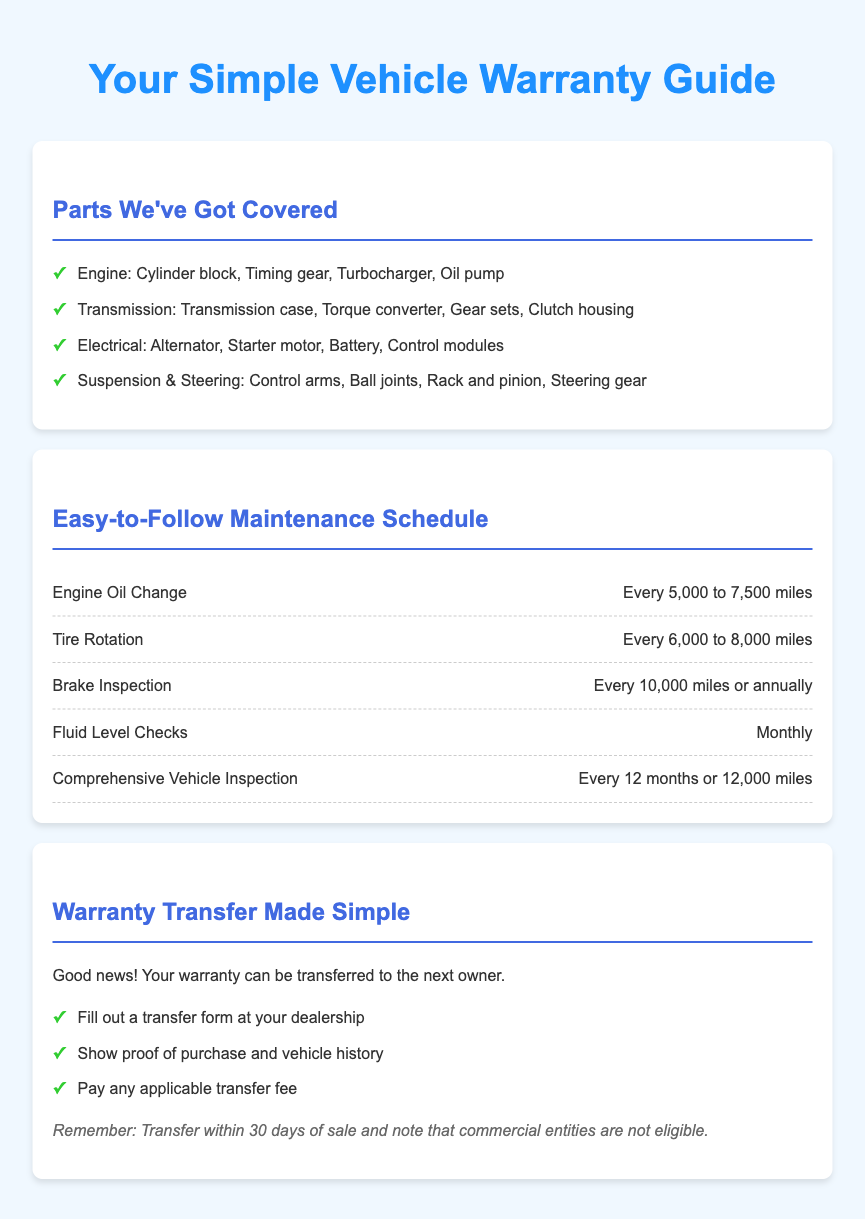What parts are covered under warranty? The sections listed in the "Parts We've Got Covered" detail the specific parts included in the warranty.
Answer: Engine, Transmission, Electrical, Suspension & Steering What is the mileage for an engine oil change? The document specifies when to change engine oil under the "Easy-to-Follow Maintenance Schedule."
Answer: Every 5,000 to 7,500 miles How often should tire rotation be done? The schedule for tire rotation is detailed in the maintenance section, indicating frequency.
Answer: Every 6,000 to 8,000 miles What must you show to transfer the warranty? It mentions necessary documentation for the warranty transfer process in the "Warranty Transfer Made Simple" section.
Answer: Proof of purchase and vehicle history What is the timeline for warranty transfer after sale? The transfer policy states the time limit for completing the transfer process.
Answer: Within 30 days of sale How often should a comprehensive vehicle inspection be conducted? The specifics are provided in the maintenance schedule regarding the inspection frequency.
Answer: Every 12 months or 12,000 miles Are commercial entities eligible for warranty transfer? This is a specific condition mentioned about eligibility in the transfer policy.
Answer: No What component includes the turbocharger? The parts section lists which components belong to the engine.
Answer: Engine How frequently are fluid level checks suggested? The recommended frequency is highlighted in the maintenance section.
Answer: Monthly 